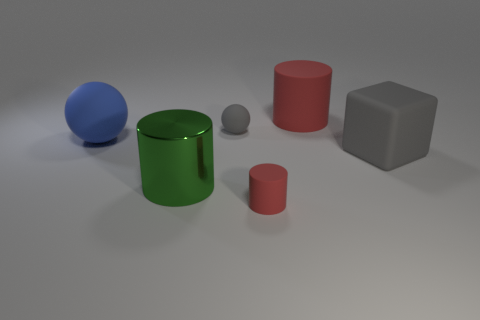The blue rubber thing is what size?
Provide a succinct answer. Large. There is a big matte cube; is its color the same as the matte thing that is in front of the metallic cylinder?
Keep it short and to the point. No. What color is the rubber ball in front of the rubber ball to the right of the big blue matte thing?
Keep it short and to the point. Blue. Is there anything else that has the same size as the blue object?
Your response must be concise. Yes. There is a tiny object in front of the gray matte cube; is its shape the same as the large red matte object?
Offer a terse response. Yes. What number of big objects are to the right of the big blue matte object and left of the gray rubber sphere?
Ensure brevity in your answer.  1. What color is the big cylinder in front of the sphere on the right side of the green metallic object that is on the left side of the tiny ball?
Offer a terse response. Green. What number of blue objects are behind the cylinder behind the large green metal thing?
Offer a terse response. 0. What number of other objects are there of the same shape as the large red rubber object?
Offer a terse response. 2. How many objects are either yellow matte things or tiny rubber things in front of the large green object?
Your answer should be very brief. 1. 